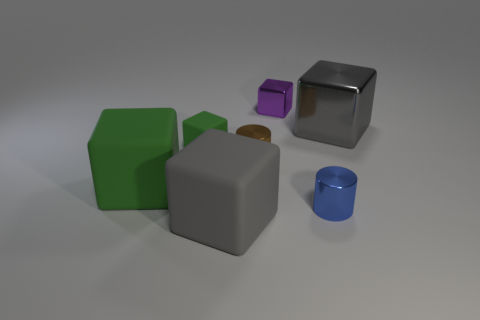Subtract all gray metal cubes. How many cubes are left? 4 Subtract all purple blocks. How many blocks are left? 4 Subtract all cyan cubes. Subtract all cyan balls. How many cubes are left? 5 Add 1 brown metallic things. How many objects exist? 8 Subtract all cylinders. How many objects are left? 5 Subtract all matte objects. Subtract all large shiny cubes. How many objects are left? 3 Add 6 tiny shiny cylinders. How many tiny shiny cylinders are left? 8 Add 7 tiny blue metallic objects. How many tiny blue metallic objects exist? 8 Subtract 0 yellow cubes. How many objects are left? 7 